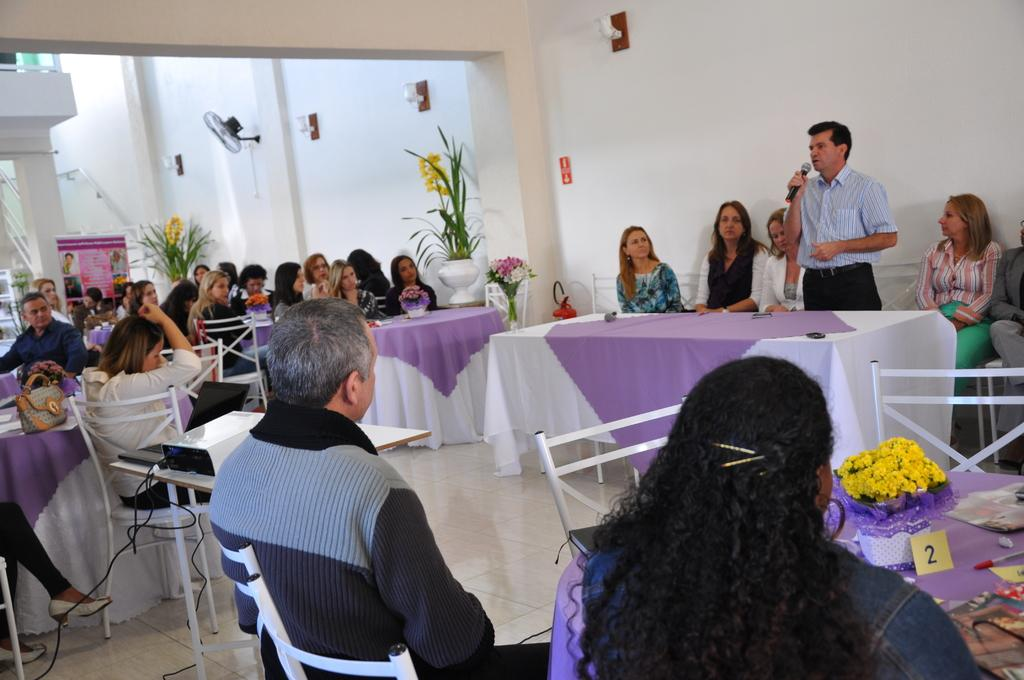What is the color of the wall in the image? The wall in the image is white. What can be seen hanging from the ceiling in the image? There is a fan in the image. Who or what is present in the image? There are people in the image. What type of furniture is visible in the image? There are chairs and tables in the image. What electronic devices are on the table in the image? There is a projector and a laptop on a table in the image. What decorative item is on the table in the image? There is a flower on a table in the image. What direction is the loaf pointing in the image? There is no loaf present in the image. What is the temperature in the north in the image? The image does not provide information about temperature or location, so it cannot be determined. 